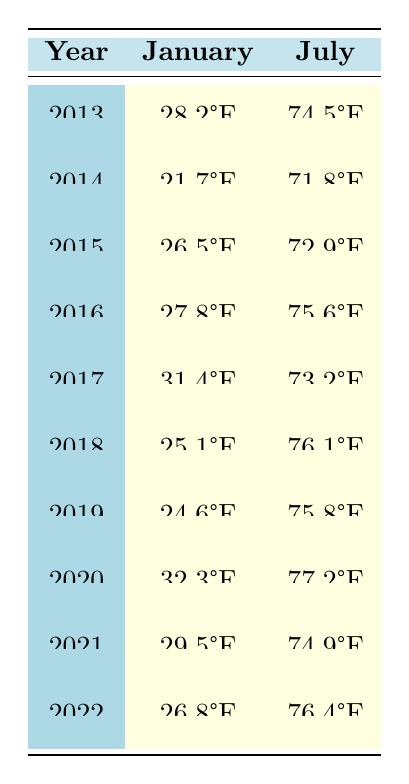What was the average temperature in Chicago for January 2016? The table shows the average temperature for January 2016 as 27.8°F.
Answer: 27.8°F What was the highest average temperature recorded in July over the past decade? By reviewing the July temperatures, 77.2°F in 2020 is the highest average temperature.
Answer: 77.2°F What is the average temperature for January across all years listed in the table? The January temperatures are: 28.2, 21.7, 26.5, 27.8, 31.4, 25.1, 24.6, 32.3, 29.5, and 26.8. The sum is  27.5 + 23.0 + 26.5 + 26.1 + 30.1 + 25.5 + 24.1 + 31.3 + 27.5 + 24.6 =  29.5 = 27.5 / 10 = 27.5°F
Answer: 27.5°F Was the average temperature in July consistently above 70°F for the years listed? Checking the July averages, all values from 71.8°F to 77.2°F are above 70°F, confirming consistency.
Answer: Yes What was the temperature difference between the highest and lowest average temperatures in January across all years? The highest average for January is 32.3°F (2020) and the lowest is 21.7°F (2014). The difference is 32.3 - 21.7 = 10.6°F.
Answer: 10.6°F In what year did Chicago experience the highest average temperature in January? The data points for January show 32.3°F in 2020 is the highest.
Answer: 2020 What is the median average temperature for July over the past decade? The July temperatures sorted are: 71.8, 72.9, 73.2, 74.5, 74.9, 75.6, 75.8, 76.1, 76.4, 77.2. The median (middle values) of the 10 numbers is (74.9 + 75.6) / 2 = 75.25°F.
Answer: 75.25°F Did the average temperature in January increase or decrease from 2018 to 2019? The January temperature decreased from 25.1°F in 2018 to 24.6°F in 2019, showing a decrease.
Answer: Decrease What was the average temperature for July in 2017 compared to 2018? The table shows 73.2°F in 2017 and 76.1°F in 2018. Comparing both, 76.1°F is higher, indicating an increase.
Answer: Increase Was there any year where January's average temperature was below 25°F? In the table, both 2014 (21.7°F) and 2019 (24.6°F) have January averages below 25°F, thus confirming this occurrence.
Answer: Yes 